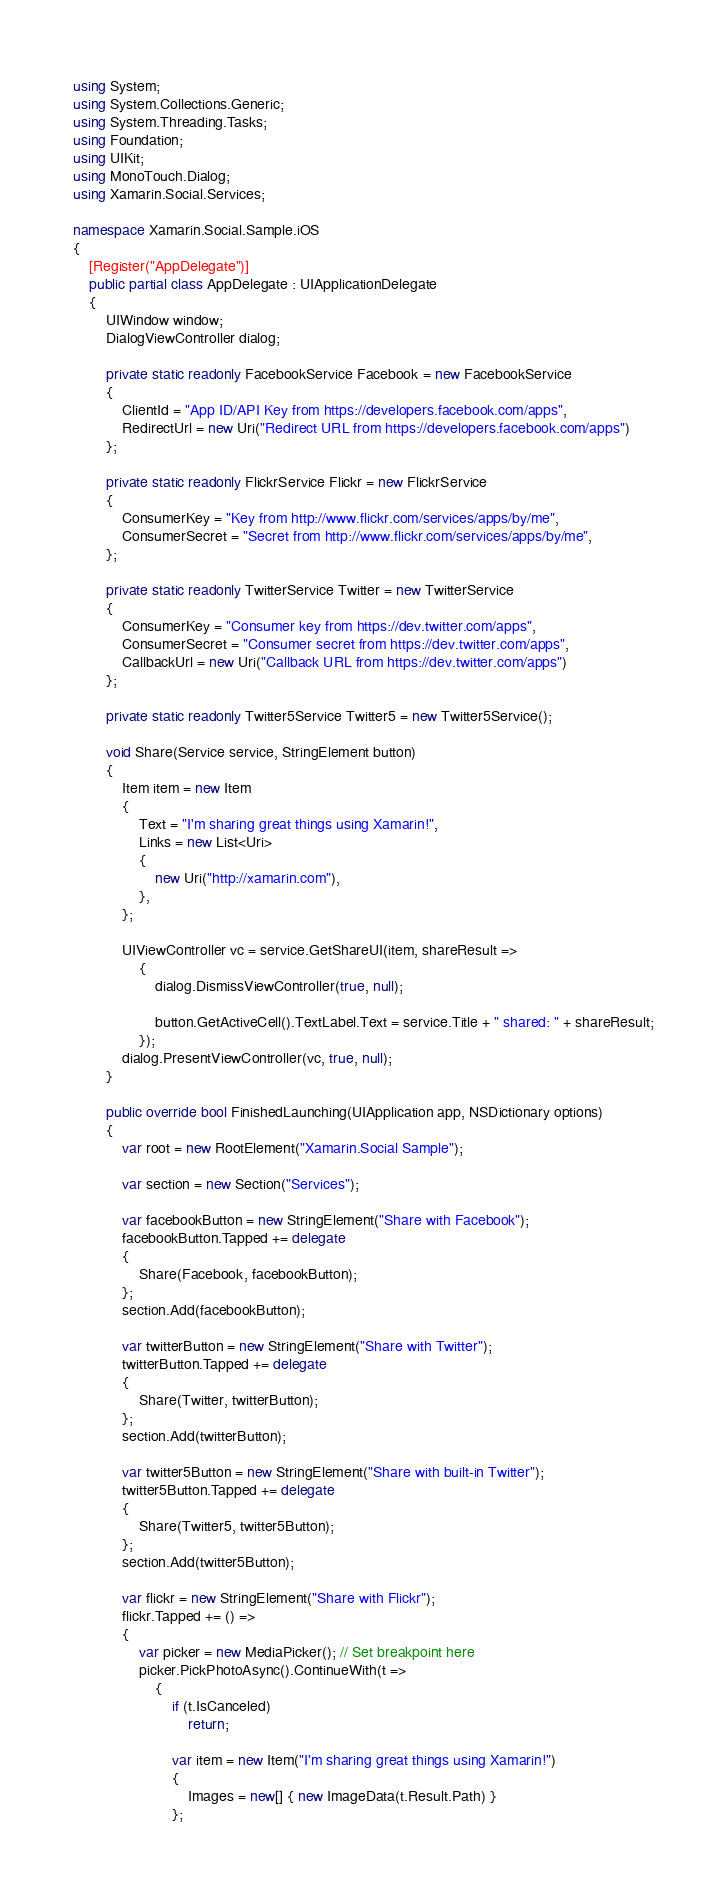Convert code to text. <code><loc_0><loc_0><loc_500><loc_500><_C#_>using System;
using System.Collections.Generic;
using System.Threading.Tasks;
using Foundation;
using UIKit;
using MonoTouch.Dialog;
using Xamarin.Social.Services;

namespace Xamarin.Social.Sample.iOS
{
    [Register("AppDelegate")]
    public partial class AppDelegate : UIApplicationDelegate
    {
        UIWindow window;
        DialogViewController dialog;

        private static readonly FacebookService Facebook = new FacebookService
        {
            ClientId = "App ID/API Key from https://developers.facebook.com/apps",
            RedirectUrl = new Uri("Redirect URL from https://developers.facebook.com/apps")
        };

        private static readonly FlickrService Flickr = new FlickrService
        {
            ConsumerKey = "Key from http://www.flickr.com/services/apps/by/me",
            ConsumerSecret = "Secret from http://www.flickr.com/services/apps/by/me",
        };

        private static readonly TwitterService Twitter = new TwitterService
        {
            ConsumerKey = "Consumer key from https://dev.twitter.com/apps",
            ConsumerSecret = "Consumer secret from https://dev.twitter.com/apps",
            CallbackUrl = new Uri("Callback URL from https://dev.twitter.com/apps")
        };

        private static readonly Twitter5Service Twitter5 = new Twitter5Service();

        void Share(Service service, StringElement button)
        {
            Item item = new Item
            {
                Text = "I'm sharing great things using Xamarin!",
                Links = new List<Uri>
                {
                    new Uri("http://xamarin.com"),
                },
            };

            UIViewController vc = service.GetShareUI(item, shareResult =>
                {
                    dialog.DismissViewController(true, null);

                    button.GetActiveCell().TextLabel.Text = service.Title + " shared: " + shareResult;
                });
            dialog.PresentViewController(vc, true, null);
        }

        public override bool FinishedLaunching(UIApplication app, NSDictionary options)
        {
            var root = new RootElement("Xamarin.Social Sample");

            var section = new Section("Services");

            var facebookButton = new StringElement("Share with Facebook");
            facebookButton.Tapped += delegate
            {
                Share(Facebook, facebookButton);
            };
            section.Add(facebookButton);

            var twitterButton = new StringElement("Share with Twitter");
            twitterButton.Tapped += delegate
            {
                Share(Twitter, twitterButton);
            };
            section.Add(twitterButton);

            var twitter5Button = new StringElement("Share with built-in Twitter");
            twitter5Button.Tapped += delegate
            {
                Share(Twitter5, twitter5Button);
            };
            section.Add(twitter5Button);

            var flickr = new StringElement("Share with Flickr");
            flickr.Tapped += () =>
            {
                var picker = new MediaPicker(); // Set breakpoint here
                picker.PickPhotoAsync().ContinueWith(t =>
                    {
                        if (t.IsCanceled)
                            return;

                        var item = new Item("I'm sharing great things using Xamarin!")
                        {
                            Images = new[] { new ImageData(t.Result.Path) }
                        };
</code> 